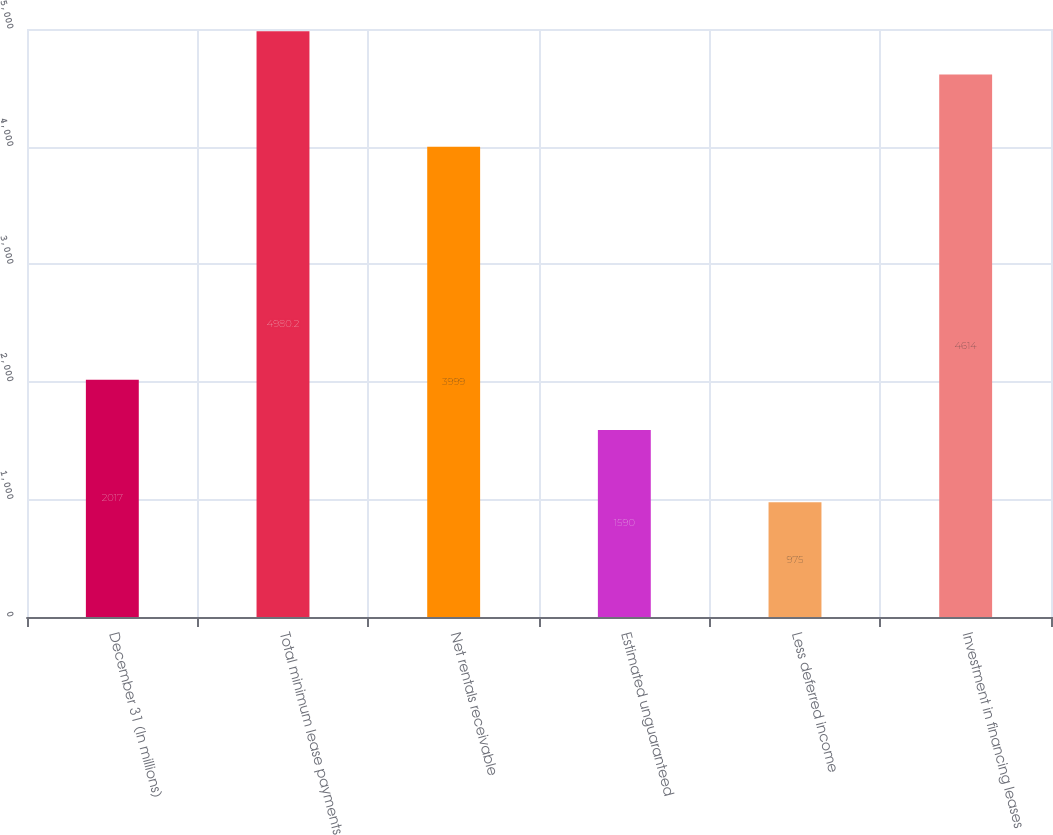<chart> <loc_0><loc_0><loc_500><loc_500><bar_chart><fcel>December 31 (In millions)<fcel>Total minimum lease payments<fcel>Net rentals receivable<fcel>Estimated unguaranteed<fcel>Less deferred income<fcel>Investment in financing leases<nl><fcel>2017<fcel>4980.2<fcel>3999<fcel>1590<fcel>975<fcel>4614<nl></chart> 